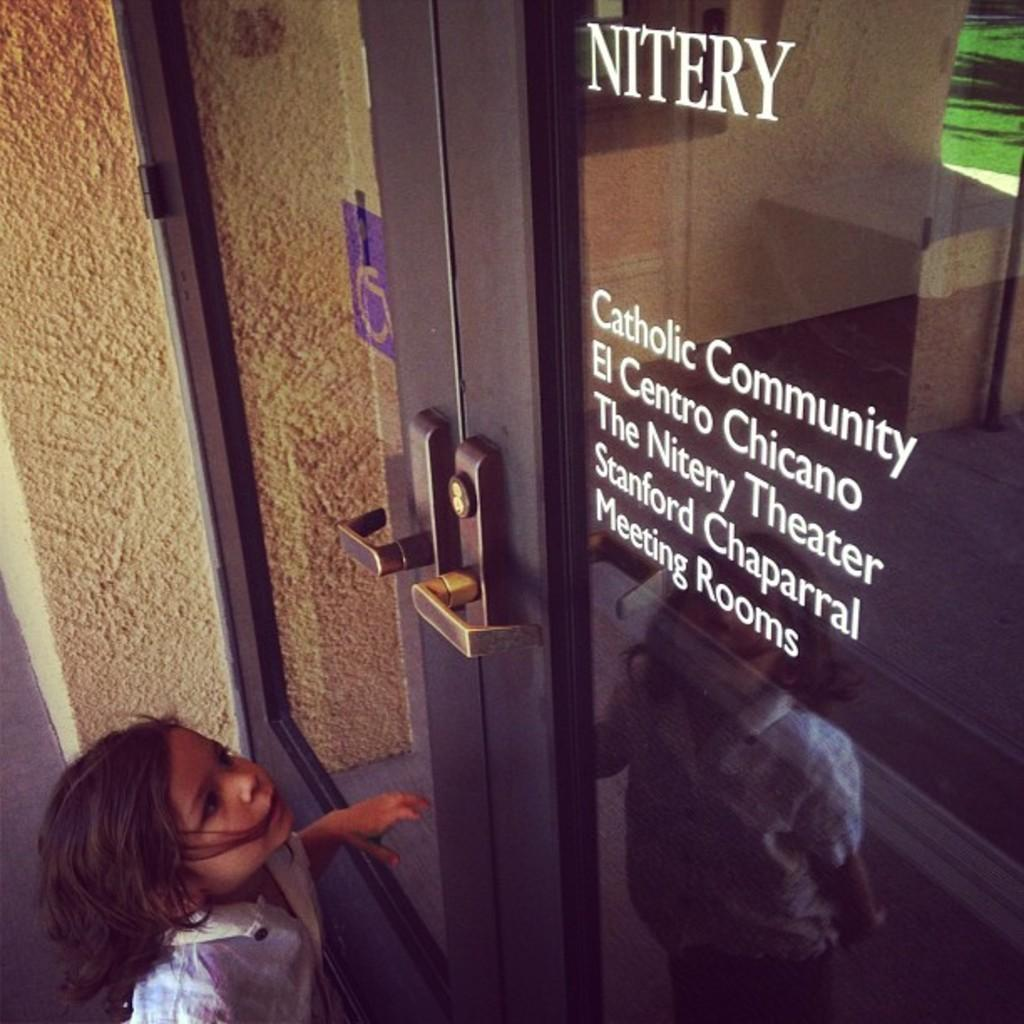Who is at the bottom of the image? There is a girl at the bottom of the image. What can be seen behind the girl? There is a wall in the image. Is there any entrance or exit visible in the image? Yes, there is a door in the image. How does the wind affect the girl's hair in the image? There is no wind present in the image, so it cannot affect the girl's hair. 